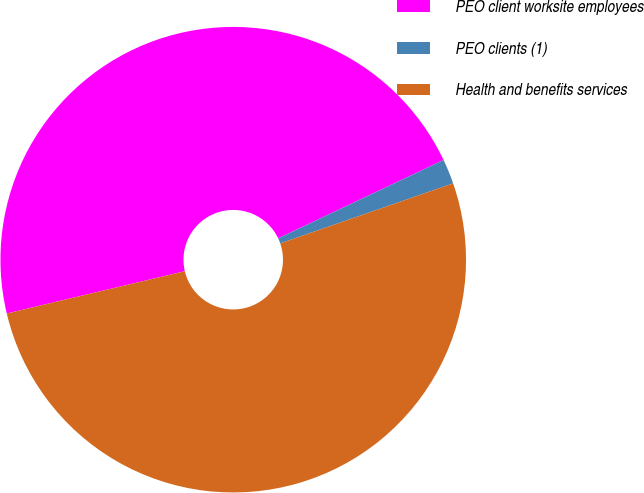Convert chart. <chart><loc_0><loc_0><loc_500><loc_500><pie_chart><fcel>PEO client worksite employees<fcel>PEO clients (1)<fcel>Health and benefits services<nl><fcel>46.67%<fcel>1.73%<fcel>51.6%<nl></chart> 